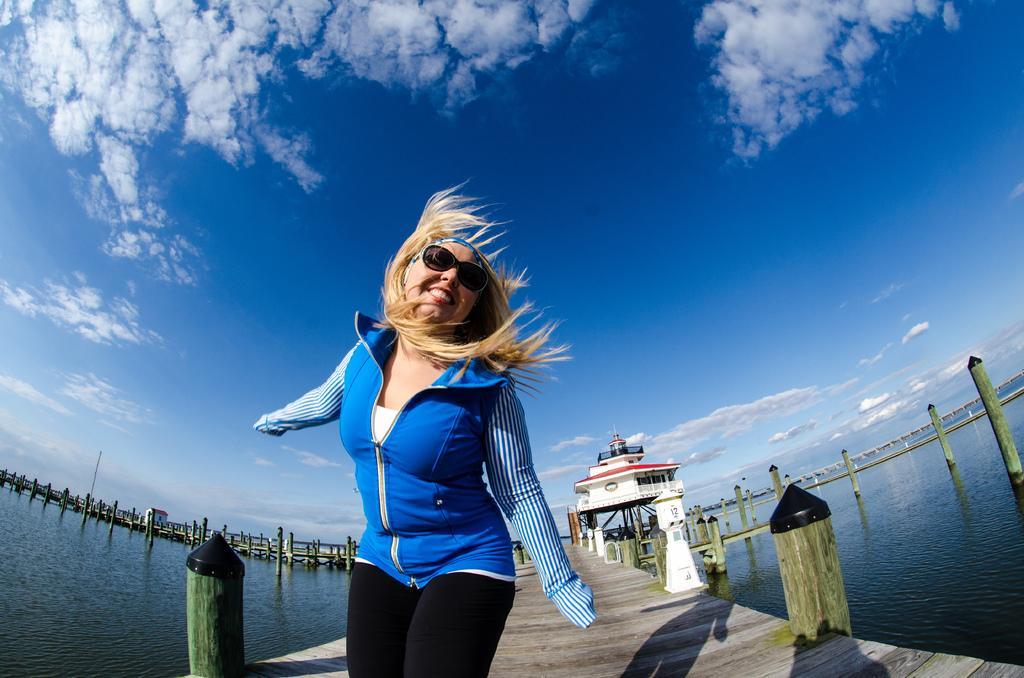Could you give a brief overview of what you see in this image? In this picture there is a woman who is wearing goggles, jacket and trouser. He is standing on the wooden bridge. In the back I can see the building, shed, bridge and poles. On the right and left side I can see the river. At the top i can see the sky and clouds. 